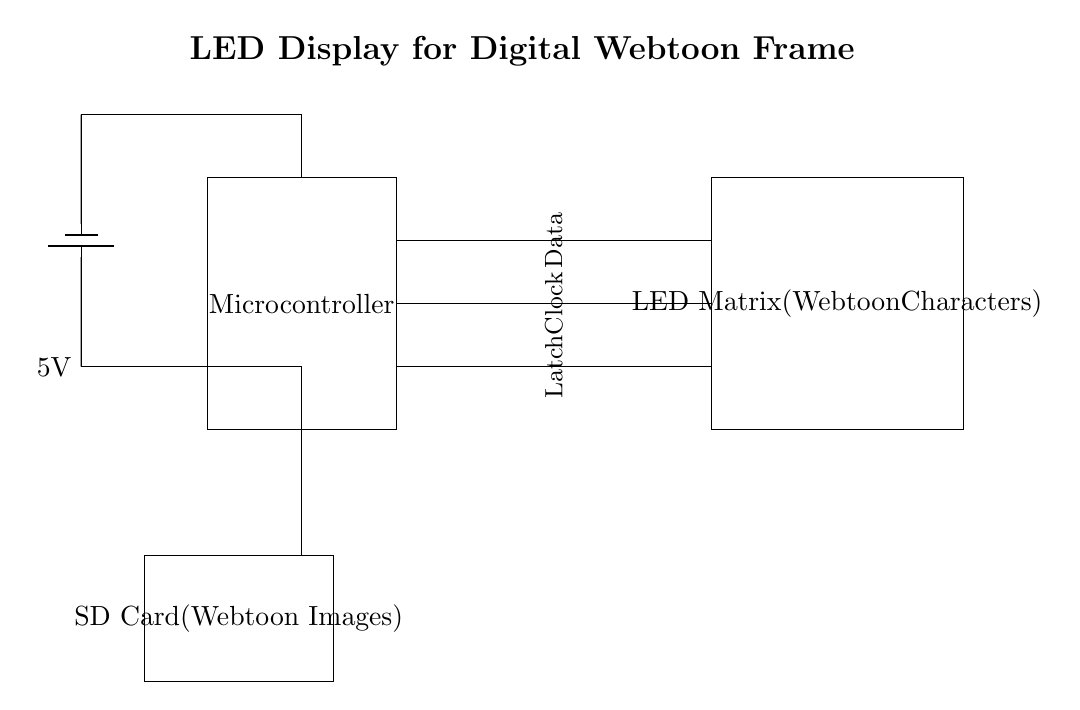What is the main component of this circuit? The main component is the microcontroller, which is essential for controlling the LED matrix and managing data input from the SD card.
Answer: Microcontroller What is the power supply voltage? The voltage is shown as 5V from the battery, which powers the circuit components.
Answer: 5V How many signal lines are used for the data connections? There are three signal lines connecting the microcontroller to the LED matrix: data, clock, and latch.
Answer: Three What is the purpose of the SD card in this circuit? The SD card is used to store webtoon images that will be displayed on the LED matrix, enabling the microcontroller to access these images for rendering.
Answer: Store images What does the clock signal do in this circuit? The clock signal is used to synchronize data transmission between the microcontroller and the LED matrix, ensuring that the data is sent and received at the correct times.
Answer: Synchronize data What type of display does this circuit drive? The circuit drives an LED matrix, which is capable of displaying webtoon characters through a matrix of LEDs that light up in patterns.
Answer: LED matrix 